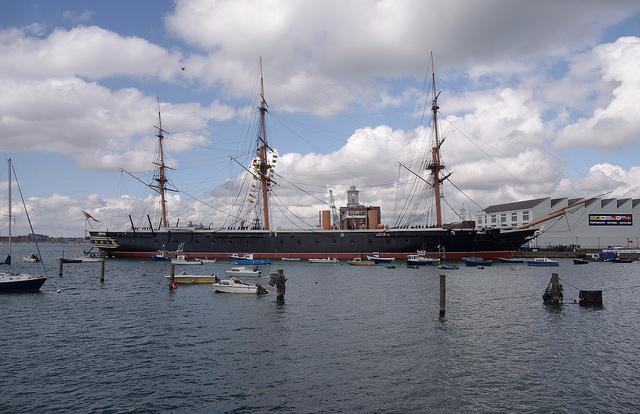What mode of transport is in the above picture?

Choices:
A) railway
B) air
C) water
D) road water 